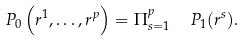Convert formula to latex. <formula><loc_0><loc_0><loc_500><loc_500>P _ { 0 } \left ( { r } ^ { 1 } , \dots , { r } ^ { p } \right ) = \Pi _ { s = 1 } ^ { p } \ \ P _ { 1 } ( { r } ^ { s } ) .</formula> 